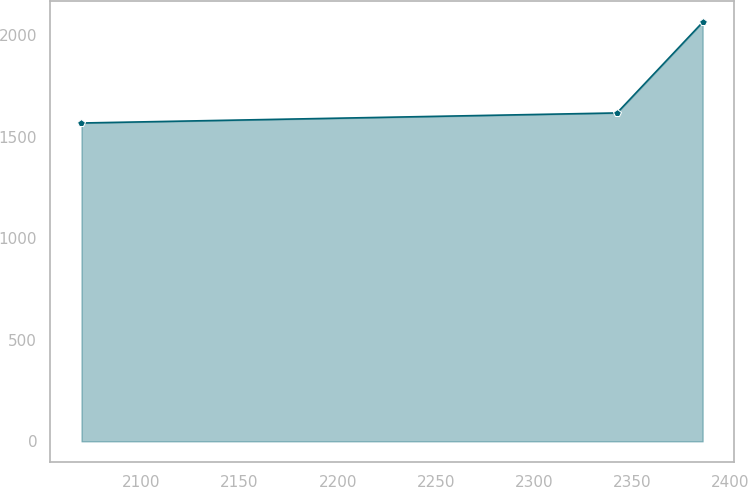Convert chart to OTSL. <chart><loc_0><loc_0><loc_500><loc_500><line_chart><ecel><fcel>Unnamed: 1<nl><fcel>2069.38<fcel>1566.46<nl><fcel>2342.44<fcel>1616.04<nl><fcel>2386.09<fcel>2062.27<nl></chart> 